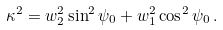Convert formula to latex. <formula><loc_0><loc_0><loc_500><loc_500>\kappa ^ { 2 } = w _ { 2 } ^ { 2 } \sin ^ { 2 } \psi _ { 0 } + w _ { 1 } ^ { 2 } \cos ^ { 2 } \psi _ { 0 } \, .</formula> 